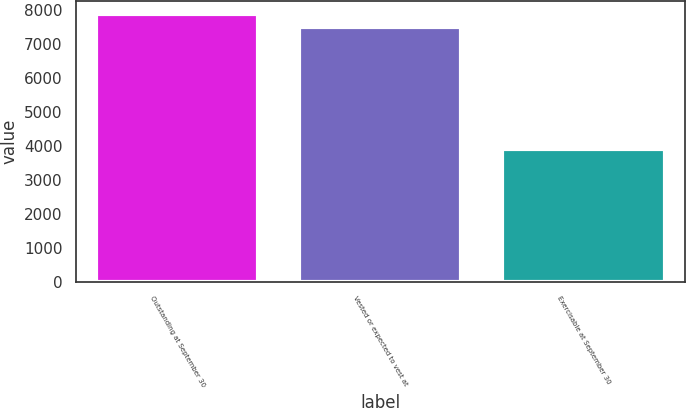Convert chart to OTSL. <chart><loc_0><loc_0><loc_500><loc_500><bar_chart><fcel>Outstanding at September 30<fcel>Vested or expected to vest at<fcel>Exercisable at September 30<nl><fcel>7867<fcel>7480<fcel>3911<nl></chart> 